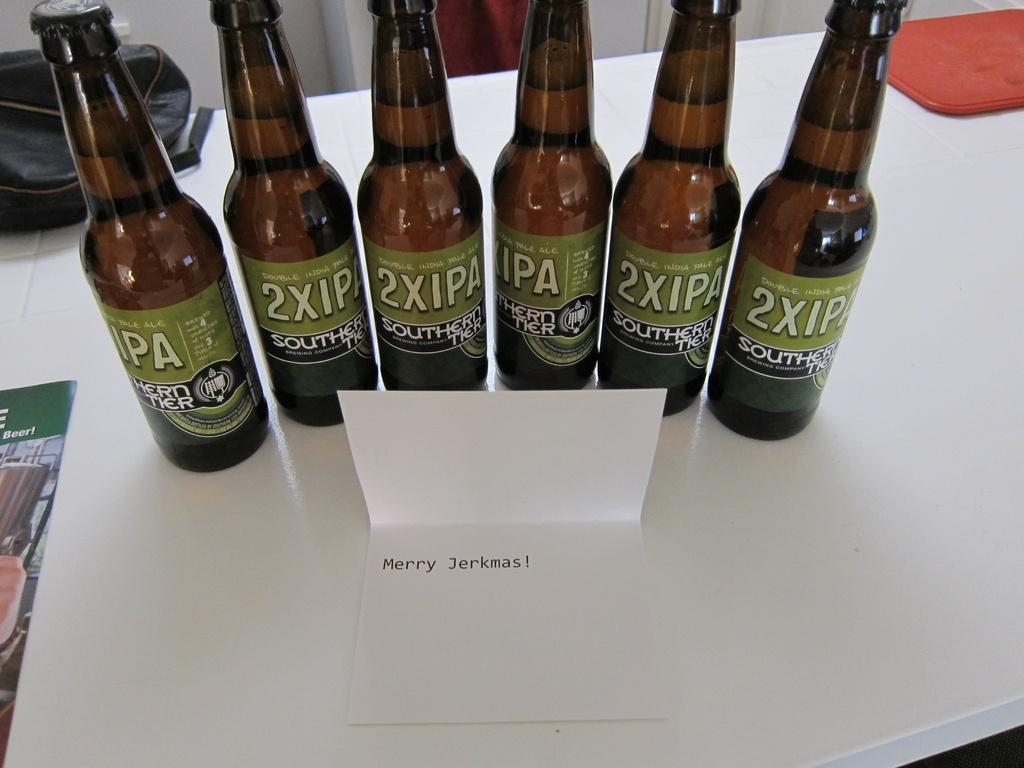<image>
Summarize the visual content of the image. Several bottles of 2XIPA are lined up near a card that says Merry Jerkmas! 